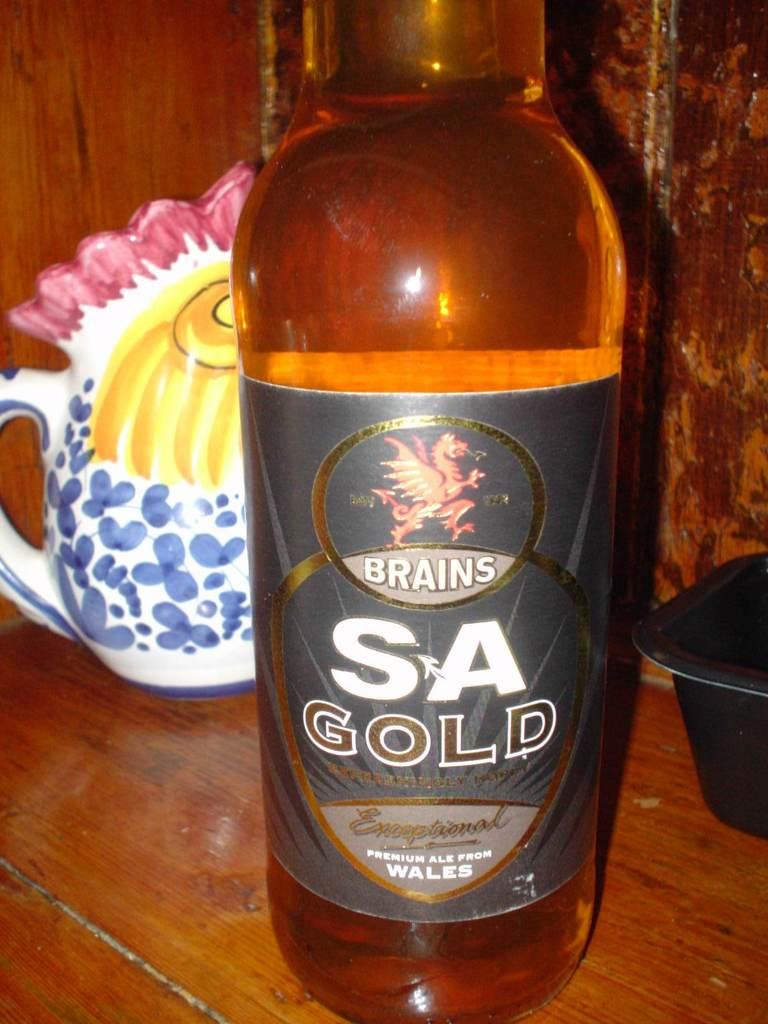<image>
Summarize the visual content of the image. A bottle of Brains SA Gold is on a wood table. 